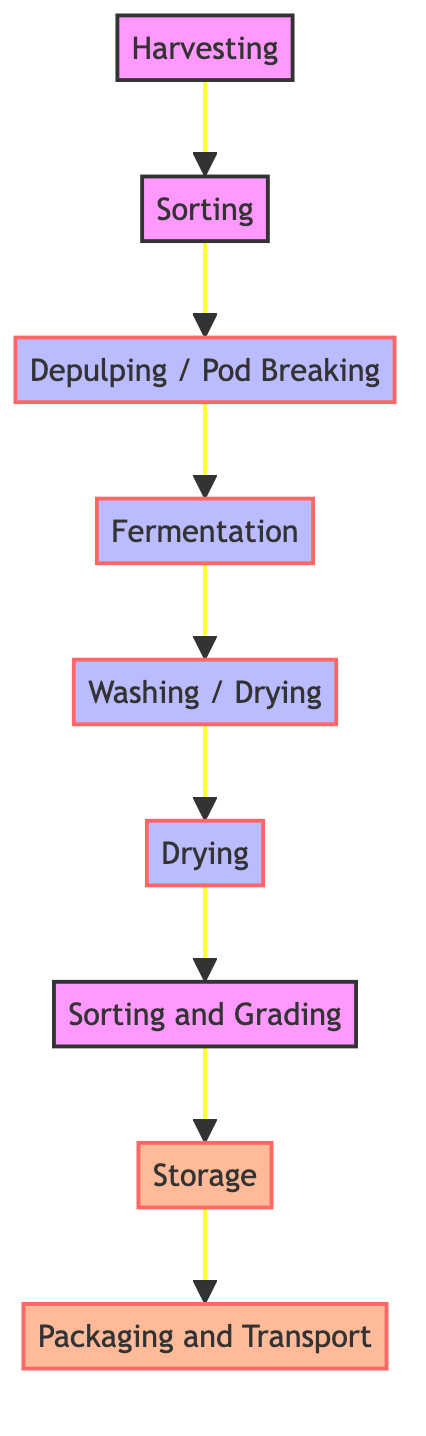What is the first step in the post-harvest processing? The diagram shows that the first step in the post-harvest processing is "Harvesting." This is indicated as the starting point of the flowchart before any other processes occur.
Answer: Harvesting How many steps are there in total? Counting all the nodes in the flowchart, there are nine distinct steps listed: Harvesting, Sorting, Depulping / Pod Breaking, Fermentation, Washing / Drying, Drying, Sorting and Grading, Storage, and Packaging and Transport. Therefore, the total number of steps is nine.
Answer: 9 What happens after Sorting? Following the "Sorting" step in the diagram, the next step is "Depulping / Pod Breaking." This indicates that after sorting the crops, the processing continues with depulping the coffee cherries or breaking open the cacao pods.
Answer: Depulping / Pod Breaking How are coffee and cacao treated during the Washing / Drying step? The diagram specifies that during the Washing / Drying step, coffee beans are washed to remove mucilage while cacao beans are spread to dry in the sun. This distinction shows how the two crops are treated differently at this stage.
Answer: Wash / Dry Which step comes before Sorting and Grading? The flowchart indicates that "Drying" is the step that occurs immediately before "Sorting and Grading." This means that after drying, the crops are sorted and graded based on size, weight, and quality.
Answer: Drying What is the last step in the processing sequence? According to the flowchart, the last step is "Packaging and Transport." This step concludes the post-harvest processing, as it involves preparing the crops for sale or further processing.
Answer: Packaging and Transport What is the purpose of the Depulping step? The Depulping step is used to remove the pulp from the coffee cherries and to break open the cacao pods to extract the beans. This step is crucial for separating the beans from the inedible parts of the fruit.
Answer: Remove pulp / Extract beans Which step is designated specifically for storage? In the flowchart, "Storage" is the step specifically designated for storing the dried coffee and cacao beans to maintain quality until further processing. This indicates a dedicated phase for quality preservation.
Answer: Storage What processes occur during the Fermentation stage? The diagram indicates that during the Fermentation stage, coffee beans and cacao beans are fermented separately to develop their flavors, highlighting the importance of this step in the flavor profile of the respective crops.
Answer: Ferment separately 